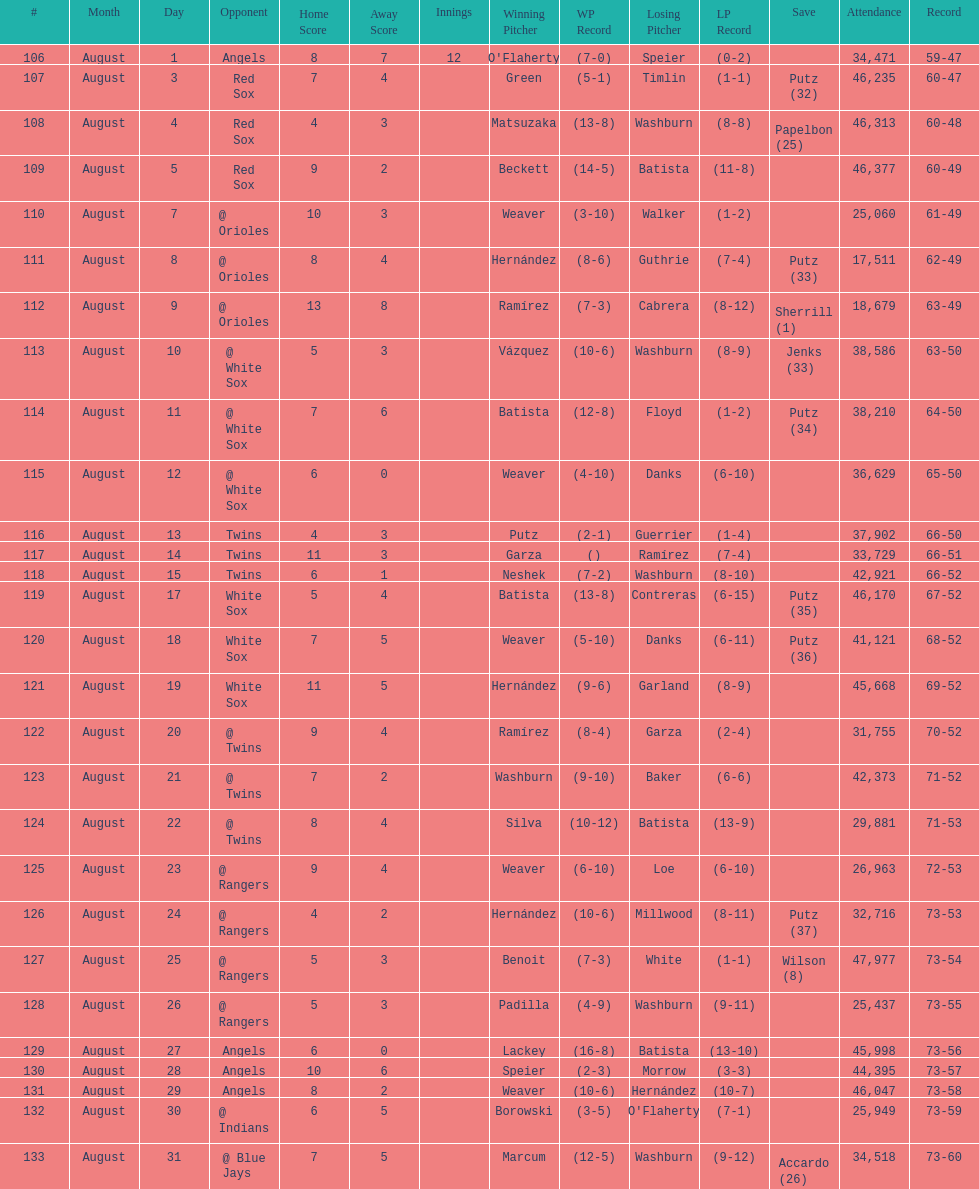Number of wins during stretch 5. 